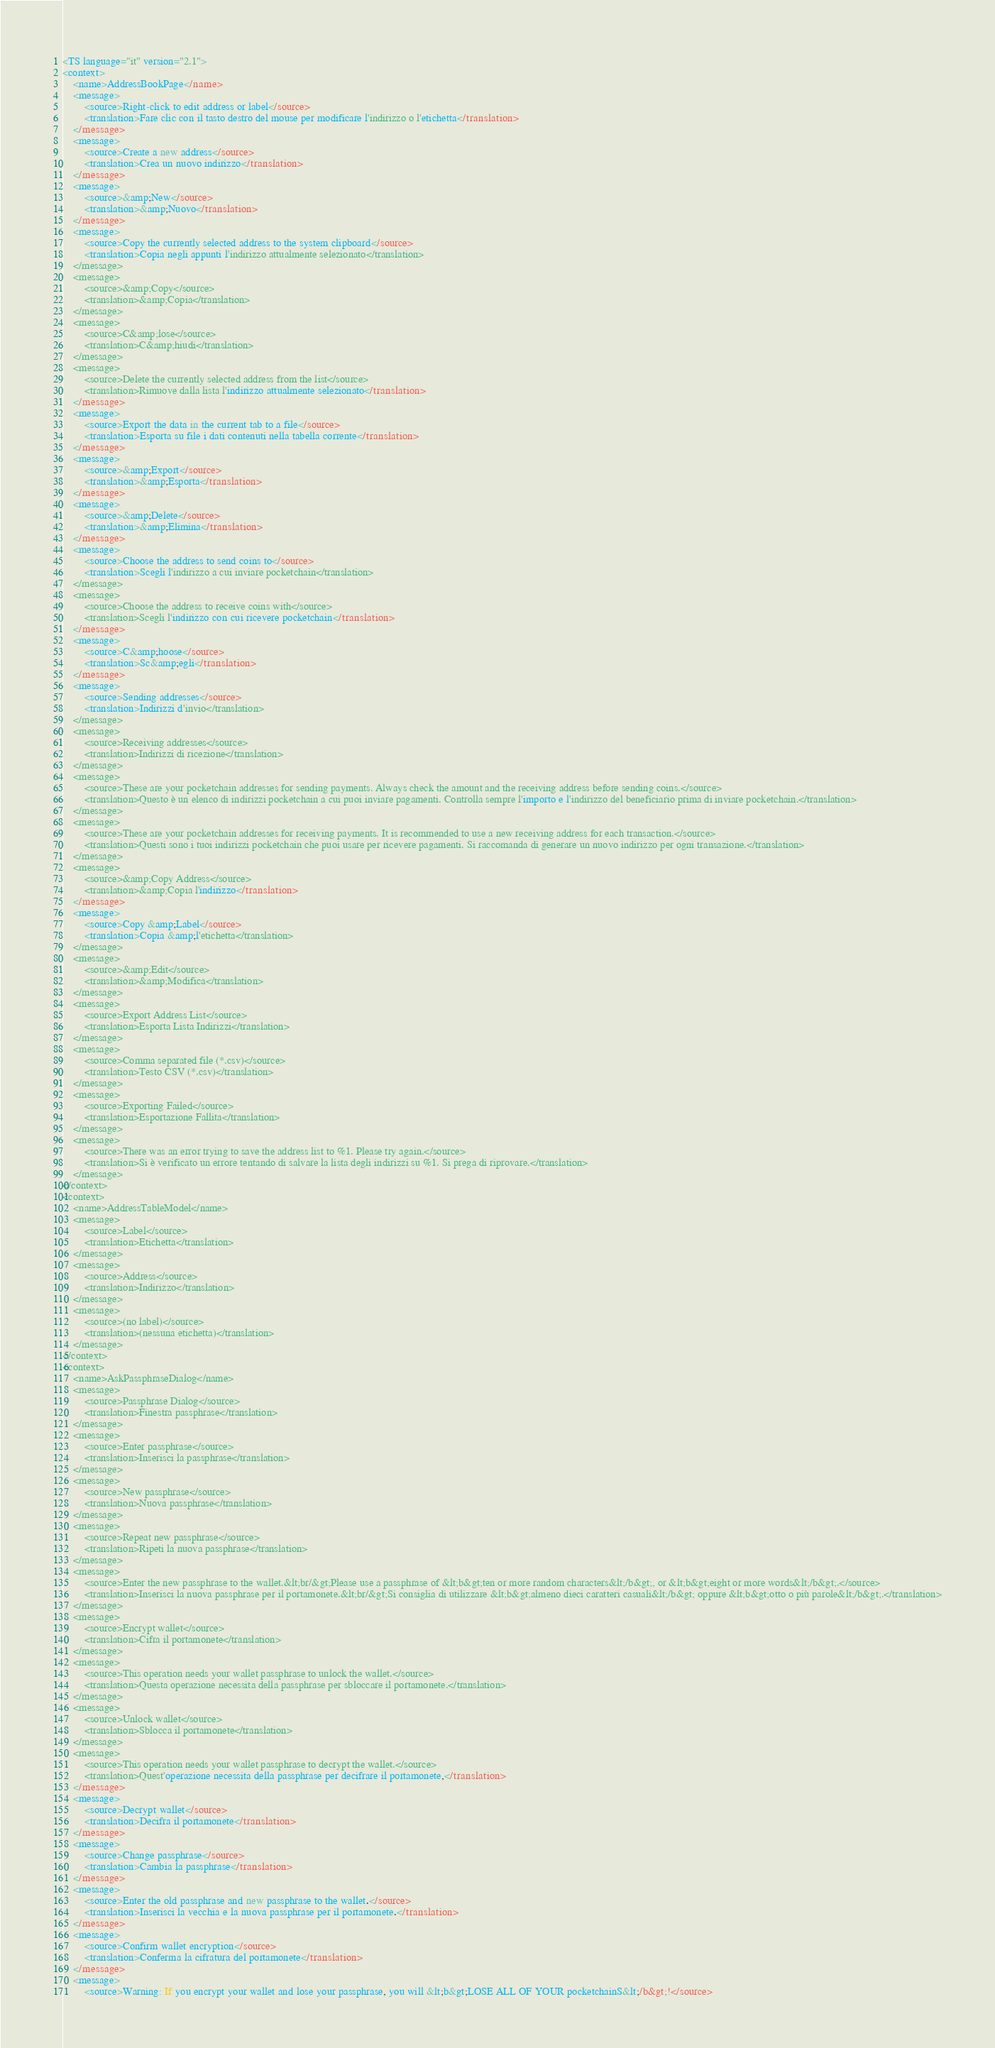<code> <loc_0><loc_0><loc_500><loc_500><_TypeScript_><TS language="it" version="2.1">
<context>
    <name>AddressBookPage</name>
    <message>
        <source>Right-click to edit address or label</source>
        <translation>Fare clic con il tasto destro del mouse per modificare l'indirizzo o l'etichetta</translation>
    </message>
    <message>
        <source>Create a new address</source>
        <translation>Crea un nuovo indirizzo</translation>
    </message>
    <message>
        <source>&amp;New</source>
        <translation>&amp;Nuovo</translation>
    </message>
    <message>
        <source>Copy the currently selected address to the system clipboard</source>
        <translation>Copia negli appunti l'indirizzo attualmente selezionato</translation>
    </message>
    <message>
        <source>&amp;Copy</source>
        <translation>&amp;Copia</translation>
    </message>
    <message>
        <source>C&amp;lose</source>
        <translation>C&amp;hiudi</translation>
    </message>
    <message>
        <source>Delete the currently selected address from the list</source>
        <translation>Rimuove dalla lista l'indirizzo attualmente selezionato</translation>
    </message>
    <message>
        <source>Export the data in the current tab to a file</source>
        <translation>Esporta su file i dati contenuti nella tabella corrente</translation>
    </message>
    <message>
        <source>&amp;Export</source>
        <translation>&amp;Esporta</translation>
    </message>
    <message>
        <source>&amp;Delete</source>
        <translation>&amp;Elimina</translation>
    </message>
    <message>
        <source>Choose the address to send coins to</source>
        <translation>Scegli l'indirizzo a cui inviare pocketchain</translation>
    </message>
    <message>
        <source>Choose the address to receive coins with</source>
        <translation>Scegli l'indirizzo con cui ricevere pocketchain</translation>
    </message>
    <message>
        <source>C&amp;hoose</source>
        <translation>Sc&amp;egli</translation>
    </message>
    <message>
        <source>Sending addresses</source>
        <translation>Indirizzi d'invio</translation>
    </message>
    <message>
        <source>Receiving addresses</source>
        <translation>Indirizzi di ricezione</translation>
    </message>
    <message>
        <source>These are your pocketchain addresses for sending payments. Always check the amount and the receiving address before sending coins.</source>
        <translation>Questo è un elenco di indirizzi pocketchain a cui puoi inviare pagamenti. Controlla sempre l'importo e l'indirizzo del beneficiario prima di inviare pocketchain.</translation>
    </message>
    <message>
        <source>These are your pocketchain addresses for receiving payments. It is recommended to use a new receiving address for each transaction.</source>
        <translation>Questi sono i tuoi indirizzi pocketchain che puoi usare per ricevere pagamenti. Si raccomanda di generare un nuovo indirizzo per ogni transazione.</translation>
    </message>
    <message>
        <source>&amp;Copy Address</source>
        <translation>&amp;Copia l'indirizzo</translation>
    </message>
    <message>
        <source>Copy &amp;Label</source>
        <translation>Copia &amp;l'etichetta</translation>
    </message>
    <message>
        <source>&amp;Edit</source>
        <translation>&amp;Modifica</translation>
    </message>
    <message>
        <source>Export Address List</source>
        <translation>Esporta Lista Indirizzi</translation>
    </message>
    <message>
        <source>Comma separated file (*.csv)</source>
        <translation>Testo CSV (*.csv)</translation>
    </message>
    <message>
        <source>Exporting Failed</source>
        <translation>Esportazione Fallita</translation>
    </message>
    <message>
        <source>There was an error trying to save the address list to %1. Please try again.</source>
        <translation>Si è verificato un errore tentando di salvare la lista degli indirizzi su %1. Si prega di riprovare.</translation>
    </message>
</context>
<context>
    <name>AddressTableModel</name>
    <message>
        <source>Label</source>
        <translation>Etichetta</translation>
    </message>
    <message>
        <source>Address</source>
        <translation>Indirizzo</translation>
    </message>
    <message>
        <source>(no label)</source>
        <translation>(nessuna etichetta)</translation>
    </message>
</context>
<context>
    <name>AskPassphraseDialog</name>
    <message>
        <source>Passphrase Dialog</source>
        <translation>Finestra passphrase</translation>
    </message>
    <message>
        <source>Enter passphrase</source>
        <translation>Inserisci la passphrase</translation>
    </message>
    <message>
        <source>New passphrase</source>
        <translation>Nuova passphrase</translation>
    </message>
    <message>
        <source>Repeat new passphrase</source>
        <translation>Ripeti la nuova passphrase</translation>
    </message>
    <message>
        <source>Enter the new passphrase to the wallet.&lt;br/&gt;Please use a passphrase of &lt;b&gt;ten or more random characters&lt;/b&gt;, or &lt;b&gt;eight or more words&lt;/b&gt;.</source>
        <translation>Inserisci la nuova passphrase per il portamonete.&lt;br/&gt;Si consiglia di utilizzare &lt;b&gt;almeno dieci caratteri casuali&lt;/b&gt; oppure &lt;b&gt;otto o più parole&lt;/b&gt;.</translation>
    </message>
    <message>
        <source>Encrypt wallet</source>
        <translation>Cifra il portamonete</translation>
    </message>
    <message>
        <source>This operation needs your wallet passphrase to unlock the wallet.</source>
        <translation>Questa operazione necessita della passphrase per sbloccare il portamonete.</translation>
    </message>
    <message>
        <source>Unlock wallet</source>
        <translation>Sblocca il portamonete</translation>
    </message>
    <message>
        <source>This operation needs your wallet passphrase to decrypt the wallet.</source>
        <translation>Quest'operazione necessita della passphrase per decifrare il portamonete,</translation>
    </message>
    <message>
        <source>Decrypt wallet</source>
        <translation>Decifra il portamonete</translation>
    </message>
    <message>
        <source>Change passphrase</source>
        <translation>Cambia la passphrase</translation>
    </message>
    <message>
        <source>Enter the old passphrase and new passphrase to the wallet.</source>
        <translation>Inserisci la vecchia e la nuova passphrase per il portamonete.</translation>
    </message>
    <message>
        <source>Confirm wallet encryption</source>
        <translation>Conferma la cifratura del portamonete</translation>
    </message>
    <message>
        <source>Warning: If you encrypt your wallet and lose your passphrase, you will &lt;b&gt;LOSE ALL OF YOUR pocketchainS&lt;/b&gt;!</source></code> 